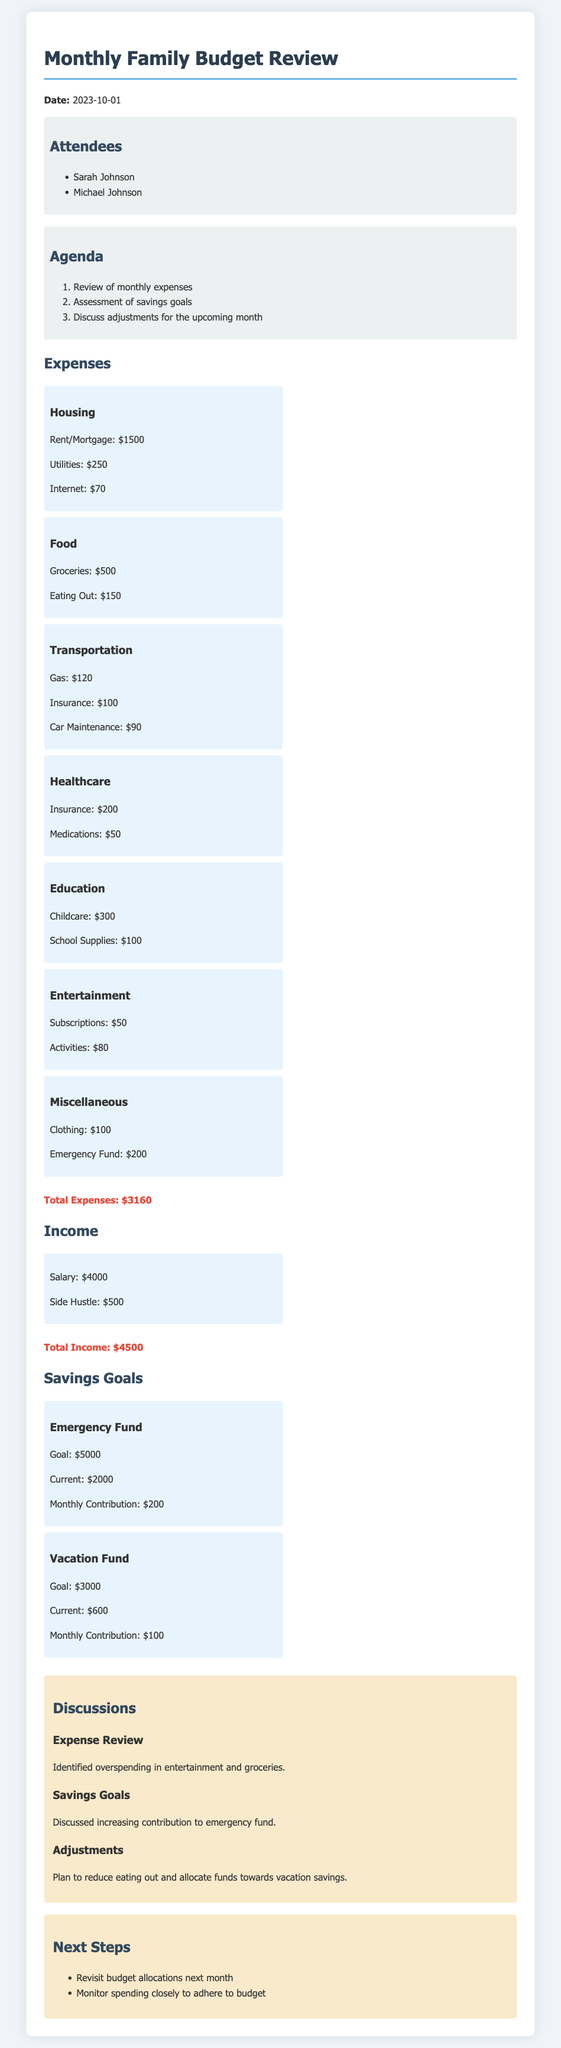what is the date of the meeting? The date of the meeting is provided at the beginning of the document.
Answer: 2023-10-01 who are the attendees of the meeting? The attendees' names are listed under the attendees section.
Answer: Sarah Johnson, Michael Johnson what is the total amount of monthly expenses? The total monthly expenses are calculated and stated at the end of the expenses section.
Answer: $3160 what is the goal amount for the emergency fund? The goal for the emergency fund is explicitly stated in the savings goals section.
Answer: $5000 how much is currently in the vacation fund? The current amount in the vacation fund is provided in the savings goals section.
Answer: $600 what adjustments were discussed for entertainment expenses? The discussion mentions specific plans regarding entertainment expenses in the discussions section.
Answer: Reduce spending how much is allocated to groceries in the monthly budget? The amount allocated to groceries is listed under the food expenses section.
Answer: $500 what did the family plan to do about eating out? The family's plan regarding eating out is mentioned in the adjustments discussion.
Answer: Reduce eating out what is the monthly contribution towards the emergency fund? The monthly contribution for the emergency fund is specified in the savings goals section.
Answer: $200 